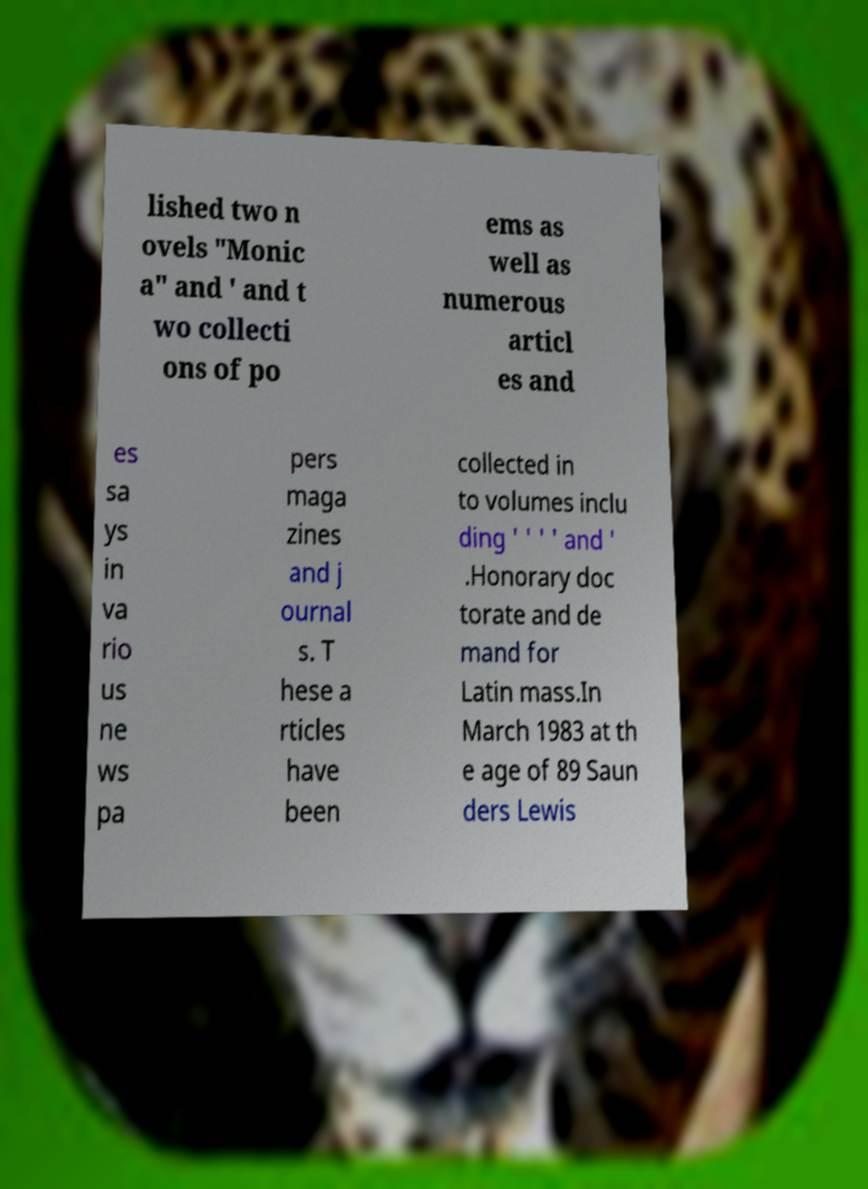I need the written content from this picture converted into text. Can you do that? lished two n ovels "Monic a" and ' and t wo collecti ons of po ems as well as numerous articl es and es sa ys in va rio us ne ws pa pers maga zines and j ournal s. T hese a rticles have been collected in to volumes inclu ding ' ' ' ' and ' .Honorary doc torate and de mand for Latin mass.In March 1983 at th e age of 89 Saun ders Lewis 